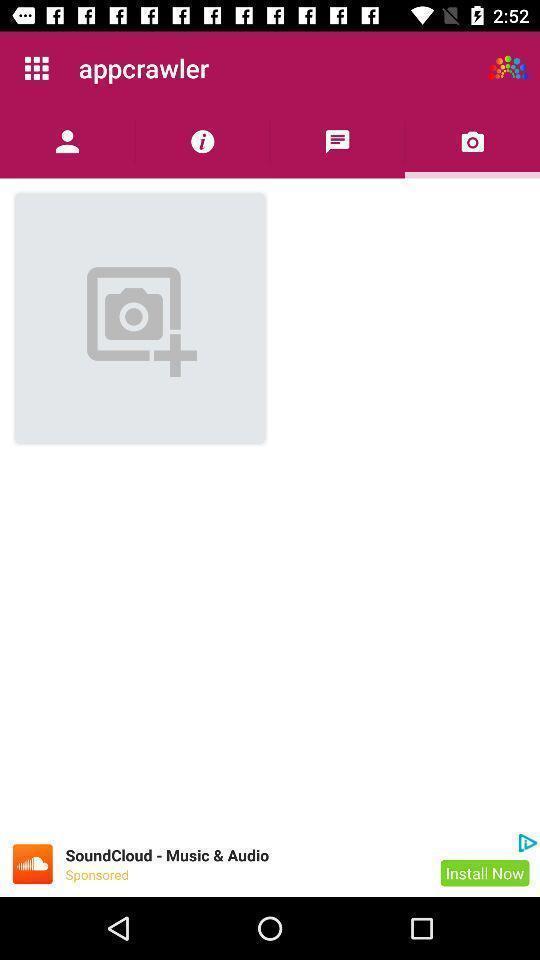Provide a detailed account of this screenshot. Page showing an icon to add photo. 